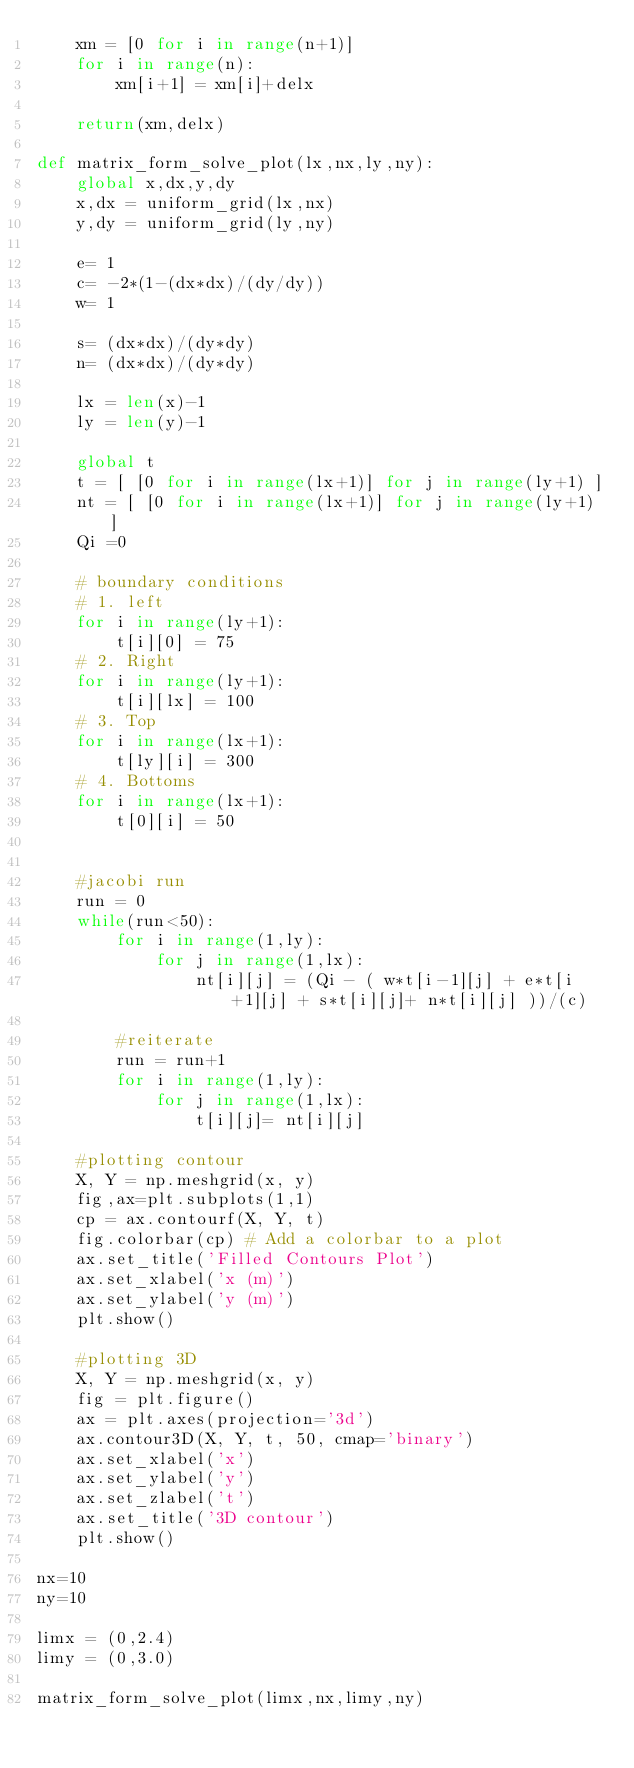Convert code to text. <code><loc_0><loc_0><loc_500><loc_500><_Python_>    xm = [0 for i in range(n+1)]
    for i in range(n):
        xm[i+1] = xm[i]+delx

    return(xm,delx)

def matrix_form_solve_plot(lx,nx,ly,ny):
    global x,dx,y,dy
    x,dx = uniform_grid(lx,nx)
    y,dy = uniform_grid(ly,ny)

    e= 1
    c= -2*(1-(dx*dx)/(dy/dy))
    w= 1

    s= (dx*dx)/(dy*dy)
    n= (dx*dx)/(dy*dy)

    lx = len(x)-1
    ly = len(y)-1

    global t
    t = [ [0 for i in range(lx+1)] for j in range(ly+1) ]
    nt = [ [0 for i in range(lx+1)] for j in range(ly+1) ]
    Qi =0

    # boundary conditions
    # 1. left
    for i in range(ly+1):
        t[i][0] = 75
    # 2. Right
    for i in range(ly+1):
        t[i][lx] = 100
    # 3. Top
    for i in range(lx+1):
        t[ly][i] = 300
    # 4. Bottoms
    for i in range(lx+1):
        t[0][i] = 50


    #jacobi run
    run = 0
    while(run<50):
        for i in range(1,ly):
            for j in range(1,lx):
                nt[i][j] = (Qi - ( w*t[i-1][j] + e*t[i+1][j] + s*t[i][j]+ n*t[i][j] ))/(c)

        #reiterate
        run = run+1
        for i in range(1,ly):
            for j in range(1,lx):
                t[i][j]= nt[i][j]

    #plotting contour
    X, Y = np.meshgrid(x, y)
    fig,ax=plt.subplots(1,1)
    cp = ax.contourf(X, Y, t)
    fig.colorbar(cp) # Add a colorbar to a plot
    ax.set_title('Filled Contours Plot')
    ax.set_xlabel('x (m)')
    ax.set_ylabel('y (m)')
    plt.show()

    #plotting 3D
    X, Y = np.meshgrid(x, y)
    fig = plt.figure()
    ax = plt.axes(projection='3d')
    ax.contour3D(X, Y, t, 50, cmap='binary')
    ax.set_xlabel('x')
    ax.set_ylabel('y')
    ax.set_zlabel('t')
    ax.set_title('3D contour')
    plt.show()

nx=10
ny=10

limx = (0,2.4)
limy = (0,3.0)

matrix_form_solve_plot(limx,nx,limy,ny)
</code> 